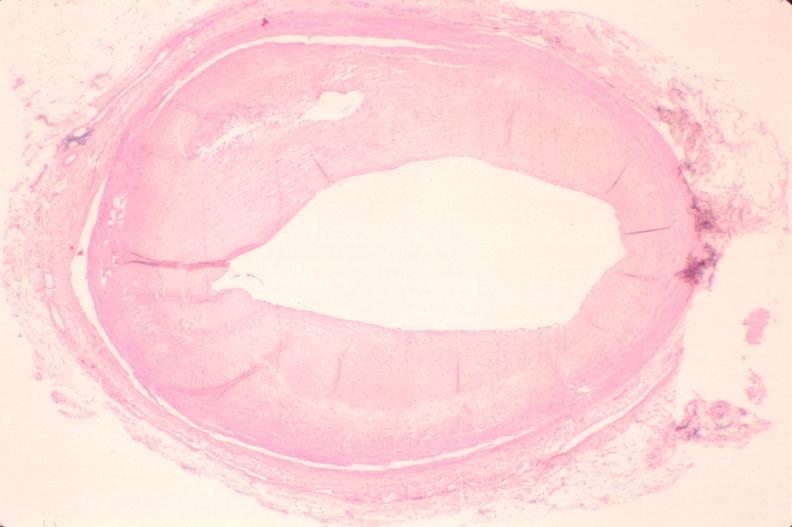s this typical lesion present?
Answer the question using a single word or phrase. No 